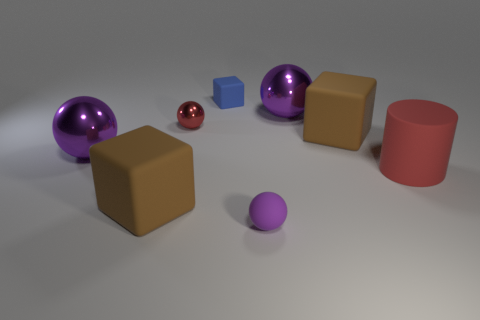How many purple spheres must be subtracted to get 1 purple spheres? 2 Subtract all red cubes. How many purple balls are left? 3 Subtract all red spheres. How many spheres are left? 3 Subtract all gray balls. Subtract all cyan cylinders. How many balls are left? 4 Add 1 blocks. How many objects exist? 9 Subtract all cubes. How many objects are left? 5 Subtract all tiny blocks. Subtract all big brown blocks. How many objects are left? 5 Add 2 big red rubber things. How many big red rubber things are left? 3 Add 3 small blue matte blocks. How many small blue matte blocks exist? 4 Subtract 0 blue balls. How many objects are left? 8 